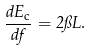Convert formula to latex. <formula><loc_0><loc_0><loc_500><loc_500>\frac { d E _ { \text {c} } } { d f } = 2 \pi L .</formula> 